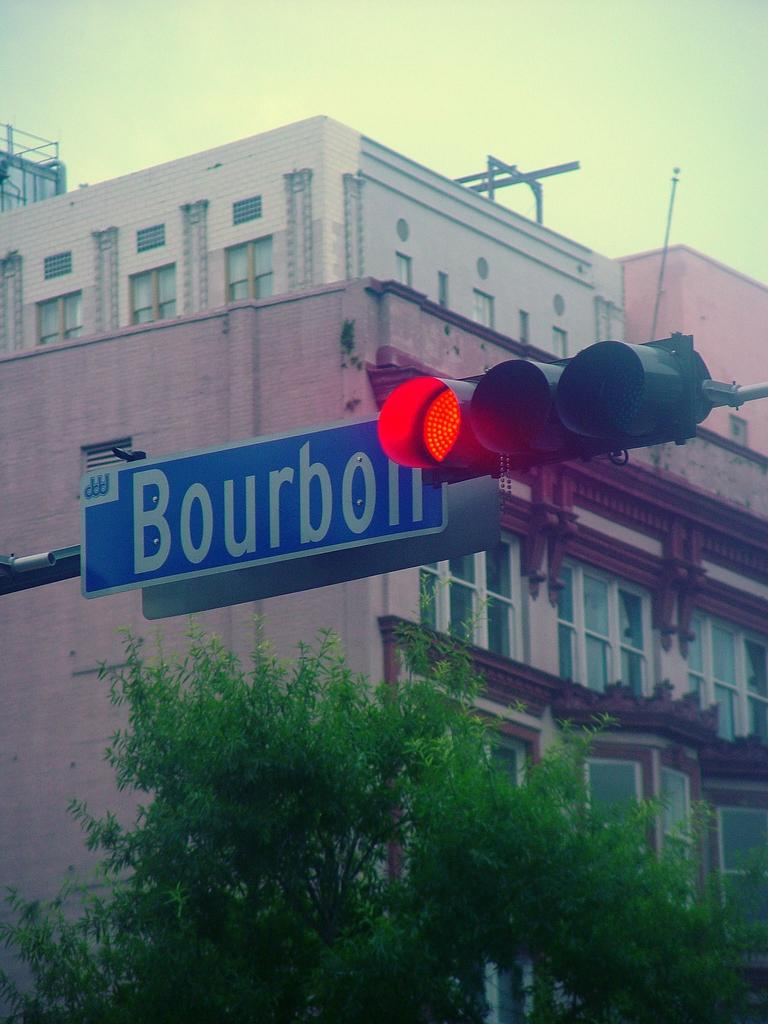<image>
Offer a succinct explanation of the picture presented. A traffic signal showing a red light is next to a blue street sign that says Bourbon. 